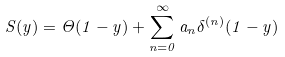Convert formula to latex. <formula><loc_0><loc_0><loc_500><loc_500>S ( y ) = \Theta ( 1 - y ) + \sum _ { n = 0 } ^ { \infty } a _ { n } \delta ^ { ( n ) } ( 1 - y )</formula> 